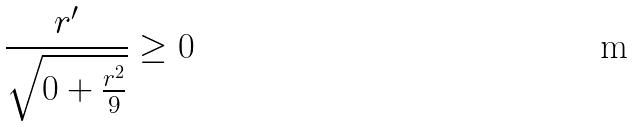Convert formula to latex. <formula><loc_0><loc_0><loc_500><loc_500>\frac { r ^ { \prime } } { \sqrt { 0 + \frac { r ^ { 2 } } { 9 } } } \geq 0</formula> 